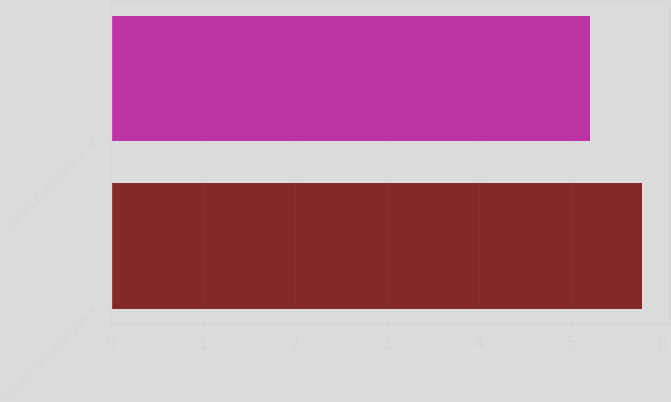Convert chart to OTSL. <chart><loc_0><loc_0><loc_500><loc_500><bar_chart><fcel>Options Outstanding as of<fcel>Options Exercisable as of<nl><fcel>5.78<fcel>5.21<nl></chart> 